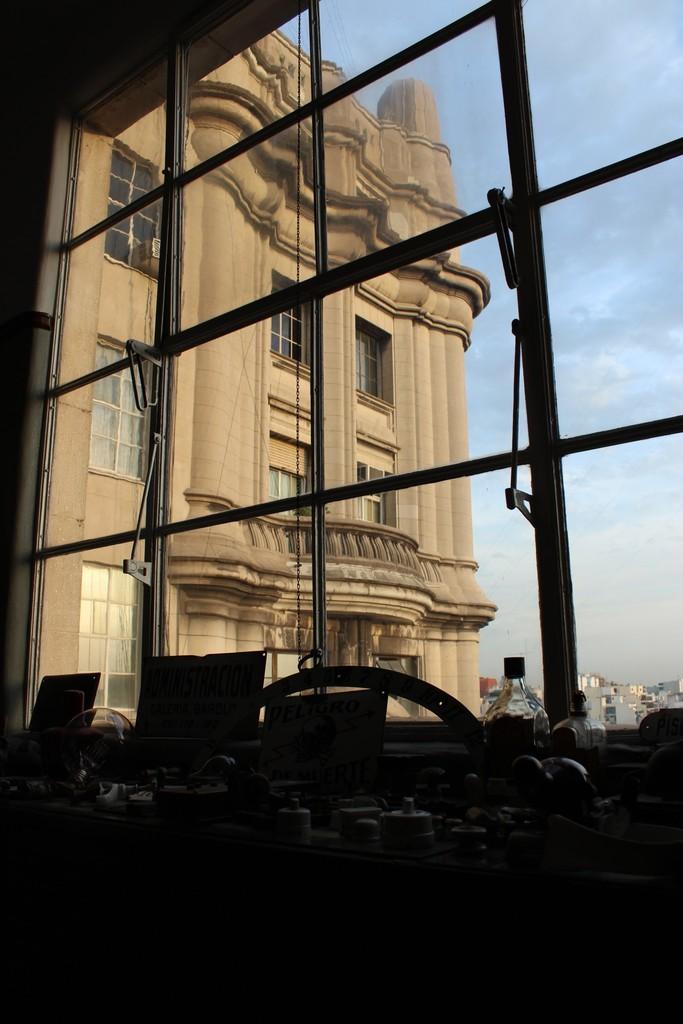Please provide a concise description of this image. In this picture I can see , there are so many items on the table inside a room, and in the background there is a window, there are houses and there is sky. 